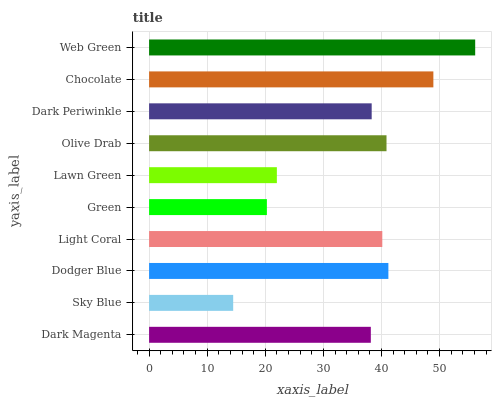Is Sky Blue the minimum?
Answer yes or no. Yes. Is Web Green the maximum?
Answer yes or no. Yes. Is Dodger Blue the minimum?
Answer yes or no. No. Is Dodger Blue the maximum?
Answer yes or no. No. Is Dodger Blue greater than Sky Blue?
Answer yes or no. Yes. Is Sky Blue less than Dodger Blue?
Answer yes or no. Yes. Is Sky Blue greater than Dodger Blue?
Answer yes or no. No. Is Dodger Blue less than Sky Blue?
Answer yes or no. No. Is Light Coral the high median?
Answer yes or no. Yes. Is Dark Periwinkle the low median?
Answer yes or no. Yes. Is Lawn Green the high median?
Answer yes or no. No. Is Green the low median?
Answer yes or no. No. 